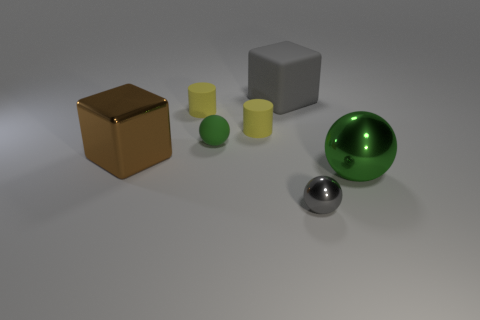What color is the cube that is behind the tiny green ball?
Provide a succinct answer. Gray. What number of tiny yellow matte cylinders are to the right of the sphere that is to the left of the gray object that is on the left side of the small gray sphere?
Provide a succinct answer. 1. There is a large thing that is to the right of the matte sphere and on the left side of the gray metallic thing; what is it made of?
Offer a terse response. Rubber. Do the brown thing and the object in front of the big green object have the same material?
Ensure brevity in your answer.  Yes. Is the number of green things that are on the left side of the gray rubber cube greater than the number of big balls that are to the left of the matte sphere?
Give a very brief answer. Yes. The green metal object is what shape?
Provide a short and direct response. Sphere. Is the cylinder left of the matte ball made of the same material as the green ball behind the large green shiny sphere?
Your answer should be very brief. Yes. What is the shape of the gray thing behind the large metallic block?
Keep it short and to the point. Cube. The other green thing that is the same shape as the tiny green thing is what size?
Give a very brief answer. Large. Does the matte cube have the same color as the tiny metallic ball?
Offer a terse response. Yes. 